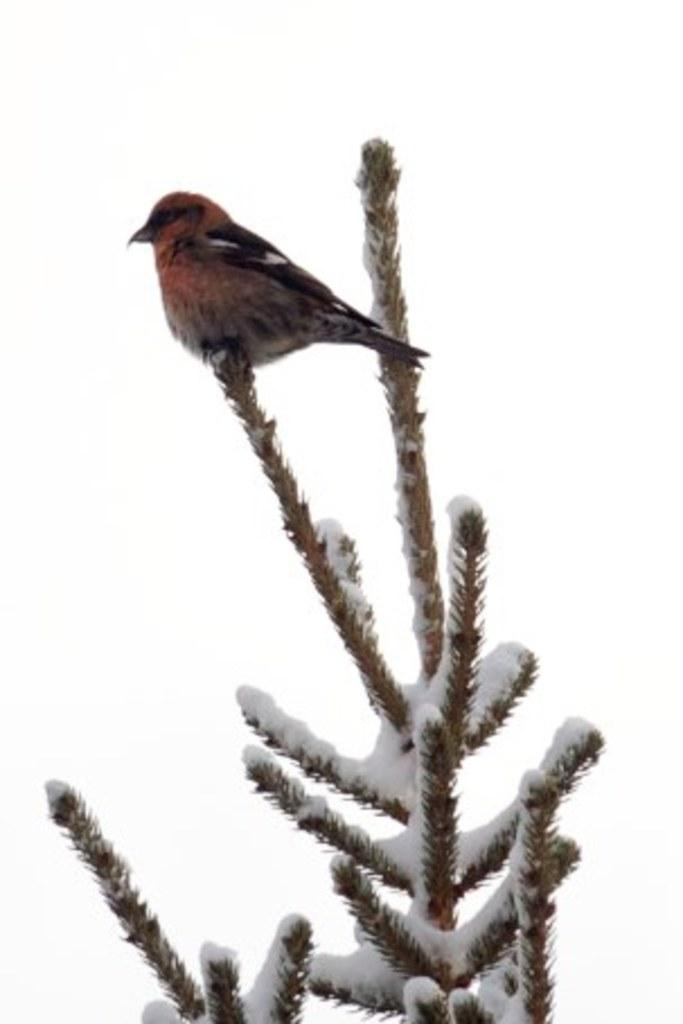What is the main subject of the image? The main subject of the image is a plant covered with snow. Are there any animals present in the image? Yes, there is a bird on the plant. What can be observed about the overall color scheme of the image? The background of the image is white. What type of shock can be seen affecting the bird in the image? There is no shock present in the image; the bird is simply perched on the snow-covered plant. 